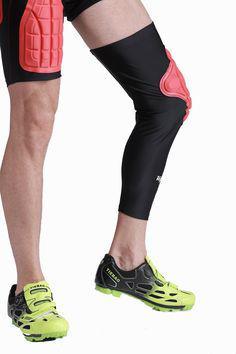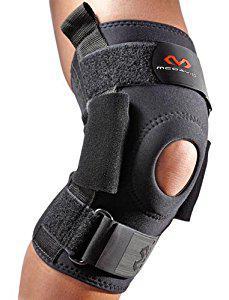The first image is the image on the left, the second image is the image on the right. For the images displayed, is the sentence "One of the knee braces has a small hole at the knee cap in an otherwise solid brace." factually correct? Answer yes or no. Yes. The first image is the image on the left, the second image is the image on the right. Considering the images on both sides, is "There is 1 or more joint wraps being displayed on a mannequin." valid? Answer yes or no. No. 